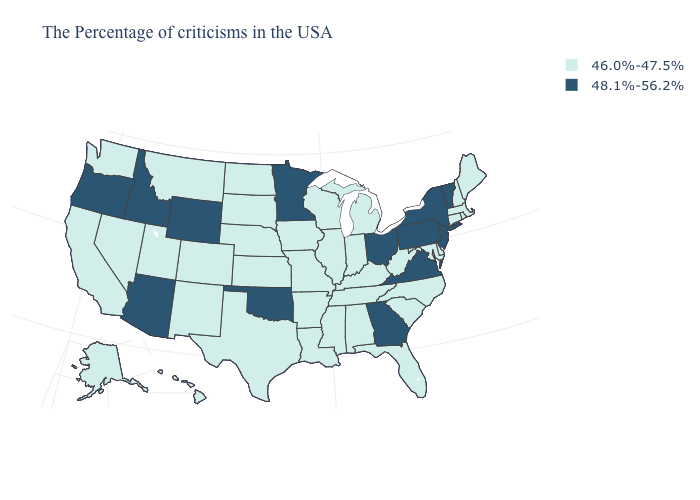Does Virginia have the highest value in the South?
Short answer required. Yes. What is the value of Hawaii?
Quick response, please. 46.0%-47.5%. What is the highest value in the South ?
Quick response, please. 48.1%-56.2%. What is the value of South Carolina?
Give a very brief answer. 46.0%-47.5%. Among the states that border North Carolina , does Virginia have the lowest value?
Keep it brief. No. What is the lowest value in the South?
Short answer required. 46.0%-47.5%. What is the value of Massachusetts?
Quick response, please. 46.0%-47.5%. Name the states that have a value in the range 48.1%-56.2%?
Short answer required. Vermont, New York, New Jersey, Pennsylvania, Virginia, Ohio, Georgia, Minnesota, Oklahoma, Wyoming, Arizona, Idaho, Oregon. Name the states that have a value in the range 46.0%-47.5%?
Short answer required. Maine, Massachusetts, Rhode Island, New Hampshire, Connecticut, Delaware, Maryland, North Carolina, South Carolina, West Virginia, Florida, Michigan, Kentucky, Indiana, Alabama, Tennessee, Wisconsin, Illinois, Mississippi, Louisiana, Missouri, Arkansas, Iowa, Kansas, Nebraska, Texas, South Dakota, North Dakota, Colorado, New Mexico, Utah, Montana, Nevada, California, Washington, Alaska, Hawaii. Does the map have missing data?
Concise answer only. No. Does the first symbol in the legend represent the smallest category?
Answer briefly. Yes. Name the states that have a value in the range 46.0%-47.5%?
Be succinct. Maine, Massachusetts, Rhode Island, New Hampshire, Connecticut, Delaware, Maryland, North Carolina, South Carolina, West Virginia, Florida, Michigan, Kentucky, Indiana, Alabama, Tennessee, Wisconsin, Illinois, Mississippi, Louisiana, Missouri, Arkansas, Iowa, Kansas, Nebraska, Texas, South Dakota, North Dakota, Colorado, New Mexico, Utah, Montana, Nevada, California, Washington, Alaska, Hawaii. Among the states that border Iowa , does South Dakota have the lowest value?
Answer briefly. Yes. What is the lowest value in the West?
Give a very brief answer. 46.0%-47.5%. What is the lowest value in the South?
Keep it brief. 46.0%-47.5%. 